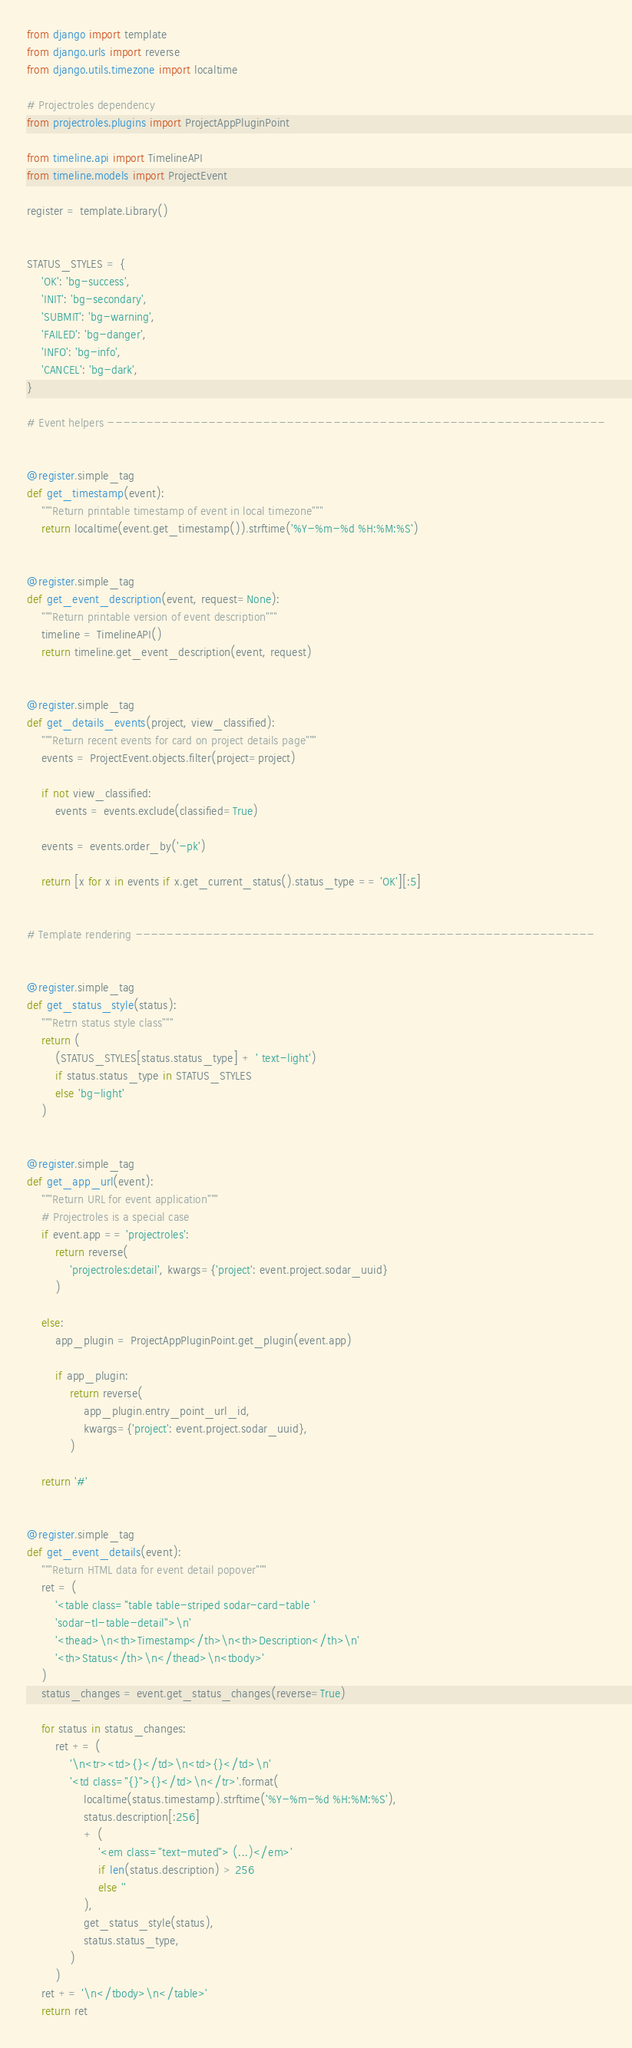Convert code to text. <code><loc_0><loc_0><loc_500><loc_500><_Python_>from django import template
from django.urls import reverse
from django.utils.timezone import localtime

# Projectroles dependency
from projectroles.plugins import ProjectAppPluginPoint

from timeline.api import TimelineAPI
from timeline.models import ProjectEvent

register = template.Library()


STATUS_STYLES = {
    'OK': 'bg-success',
    'INIT': 'bg-secondary',
    'SUBMIT': 'bg-warning',
    'FAILED': 'bg-danger',
    'INFO': 'bg-info',
    'CANCEL': 'bg-dark',
}

# Event helpers ----------------------------------------------------------------


@register.simple_tag
def get_timestamp(event):
    """Return printable timestamp of event in local timezone"""
    return localtime(event.get_timestamp()).strftime('%Y-%m-%d %H:%M:%S')


@register.simple_tag
def get_event_description(event, request=None):
    """Return printable version of event description"""
    timeline = TimelineAPI()
    return timeline.get_event_description(event, request)


@register.simple_tag
def get_details_events(project, view_classified):
    """Return recent events for card on project details page"""
    events = ProjectEvent.objects.filter(project=project)

    if not view_classified:
        events = events.exclude(classified=True)

    events = events.order_by('-pk')

    return [x for x in events if x.get_current_status().status_type == 'OK'][:5]


# Template rendering -----------------------------------------------------------


@register.simple_tag
def get_status_style(status):
    """Retrn status style class"""
    return (
        (STATUS_STYLES[status.status_type] + ' text-light')
        if status.status_type in STATUS_STYLES
        else 'bg-light'
    )


@register.simple_tag
def get_app_url(event):
    """Return URL for event application"""
    # Projectroles is a special case
    if event.app == 'projectroles':
        return reverse(
            'projectroles:detail', kwargs={'project': event.project.sodar_uuid}
        )

    else:
        app_plugin = ProjectAppPluginPoint.get_plugin(event.app)

        if app_plugin:
            return reverse(
                app_plugin.entry_point_url_id,
                kwargs={'project': event.project.sodar_uuid},
            )

    return '#'


@register.simple_tag
def get_event_details(event):
    """Return HTML data for event detail popover"""
    ret = (
        '<table class="table table-striped sodar-card-table '
        'sodar-tl-table-detail">\n'
        '<thead>\n<th>Timestamp</th>\n<th>Description</th>\n'
        '<th>Status</th>\n</thead>\n<tbody>'
    )
    status_changes = event.get_status_changes(reverse=True)

    for status in status_changes:
        ret += (
            '\n<tr><td>{}</td>\n<td>{}</td>\n'
            '<td class="{}">{}</td>\n</tr>'.format(
                localtime(status.timestamp).strftime('%Y-%m-%d %H:%M:%S'),
                status.description[:256]
                + (
                    '<em class="text-muted"> (...)</em>'
                    if len(status.description) > 256
                    else ''
                ),
                get_status_style(status),
                status.status_type,
            )
        )
    ret += '\n</tbody>\n</table>'
    return ret
</code> 